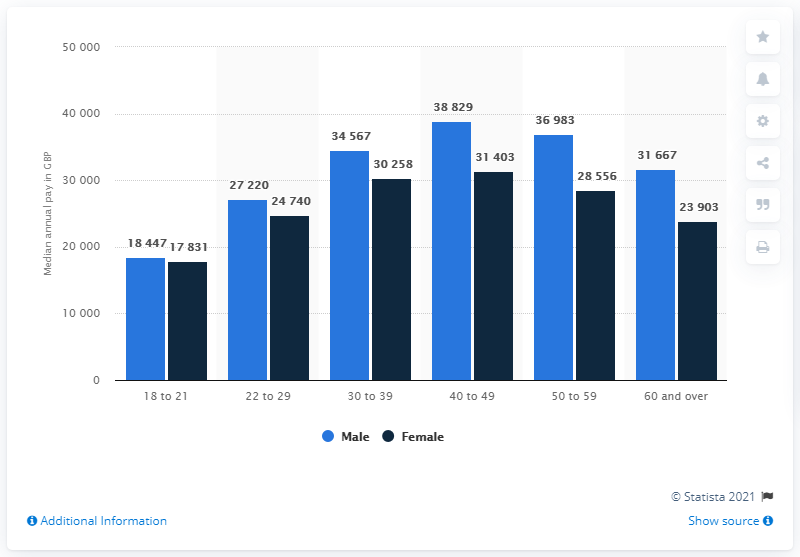Identify some key points in this picture. The average annual income for men in their 50s is approximately 36,983 US dollars. 